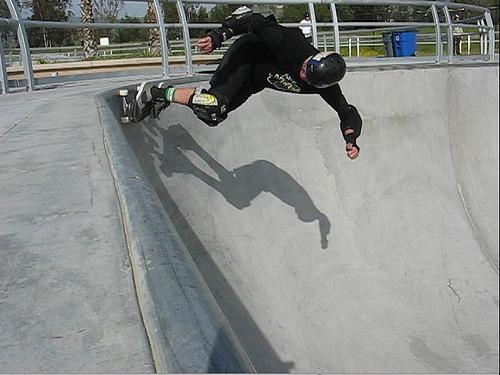Is the person wearing sneakers?
Give a very brief answer. Yes. Is the shadow on the boarders left or right?
Be succinct. Left. What is the skate bowl made from?
Be succinct. Concrete. What trick is he doing?
Give a very brief answer. Jump. 